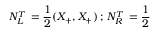<formula> <loc_0><loc_0><loc_500><loc_500>N _ { L } ^ { T } \, = \frac { 1 } { 2 } ( X _ { + } , X _ { + } ) \, ; \, N _ { R } ^ { T } \, = \frac { 1 } { 2 }</formula> 